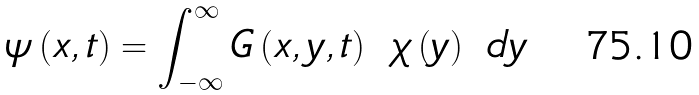<formula> <loc_0><loc_0><loc_500><loc_500>\psi \left ( x , t \right ) = \int _ { - \infty } ^ { \infty } G \left ( x , y , t \right ) \ \chi \left ( y \right ) \ d y</formula> 